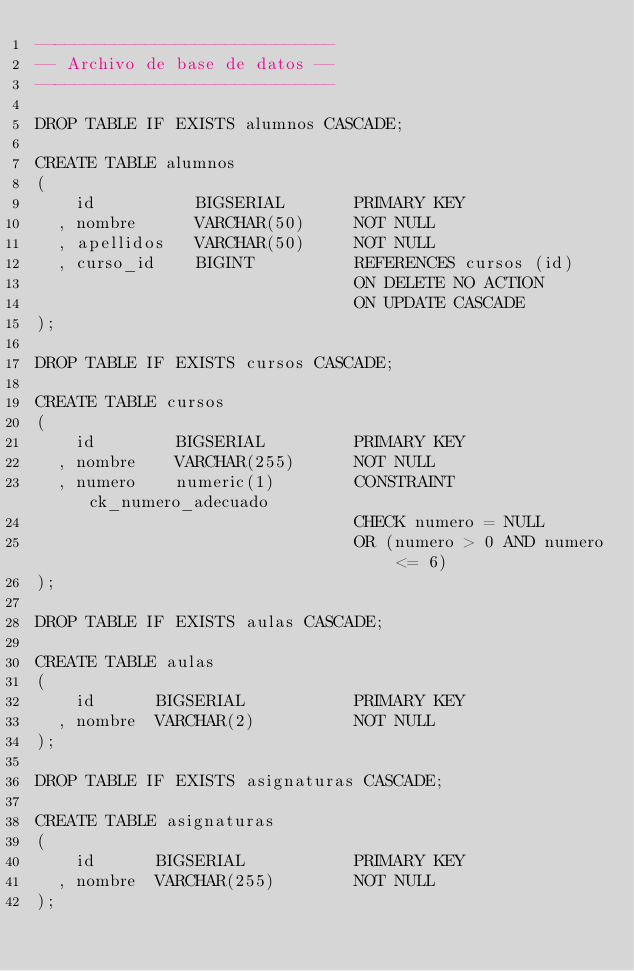Convert code to text. <code><loc_0><loc_0><loc_500><loc_500><_SQL_>------------------------------
-- Archivo de base de datos --
------------------------------

DROP TABLE IF EXISTS alumnos CASCADE;

CREATE TABLE alumnos
(
    id          BIGSERIAL       PRIMARY KEY
  , nombre      VARCHAR(50)     NOT NULL
  , apellidos   VARCHAR(50)     NOT NULL
  , curso_id    BIGINT          REFERENCES cursos (id)
                                ON DELETE NO ACTION
                                ON UPDATE CASCADE
);

DROP TABLE IF EXISTS cursos CASCADE;

CREATE TABLE cursos
(
    id        BIGSERIAL         PRIMARY KEY
  , nombre    VARCHAR(255)      NOT NULL
  , numero    numeric(1)        CONSTRAINT ck_numero_adecuado
                                CHECK numero = NULL
                                OR (numero > 0 AND numero <= 6)
);

DROP TABLE IF EXISTS aulas CASCADE;

CREATE TABLE aulas
(
    id      BIGSERIAL           PRIMARY KEY
  , nombre  VARCHAR(2)          NOT NULL
);

DROP TABLE IF EXISTS asignaturas CASCADE;

CREATE TABLE asignaturas
(
    id      BIGSERIAL           PRIMARY KEY
  , nombre  VARCHAR(255)        NOT NULL
);
</code> 